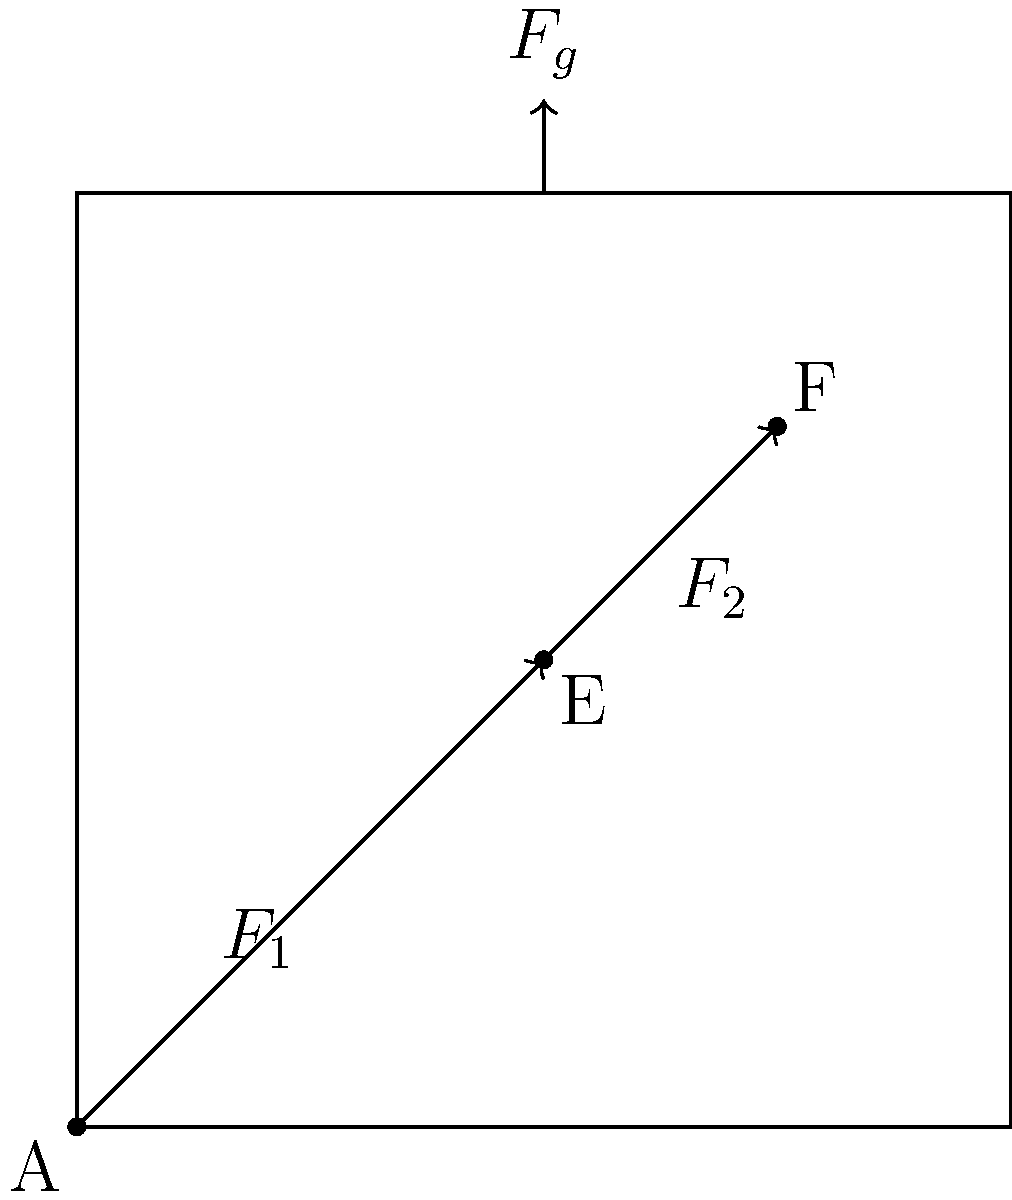In the standing desk mechanism shown, where $F_g$ represents the gravitational force on the desk surface, and $F_1$ and $F_2$ represent the forces in the lower and upper segments of the support arm respectively, which of these forces is likely to be the largest in magnitude when the desk is in a stable position? To determine which force is likely to be the largest in magnitude, we need to consider the mechanics of the standing desk:

1. The gravitational force $F_g$ acts downward on the desk surface, creating a moment about point A.

2. To counteract this moment and maintain stability, the support arm must exert an upward force through points E and F.

3. The force in the lower segment ($F_1$) and upper segment ($F_2$) of the support arm work together to provide this upward force.

4. Due to the angled configuration of the support arm, $F_1$ and $F_2$ will be larger than $F_g$ to provide the necessary vertical component to balance the desk.

5. Between $F_1$ and $F_2$, the force in the lower segment ($F_1$) will be larger because:
   a) It bears the combined load of the desk and the upper segment.
   b) It operates at a less favorable angle to the vertical, requiring a larger magnitude to provide the same vertical component.

6. Therefore, $F_1$ is likely to be the largest force in the system when the desk is stable.

This analysis is crucial for healthcare experts focusing on ergonomics, as understanding these forces helps in designing standing desks that minimize stress on users' musculoskeletal systems during adjustments.
Answer: $F_1$ 